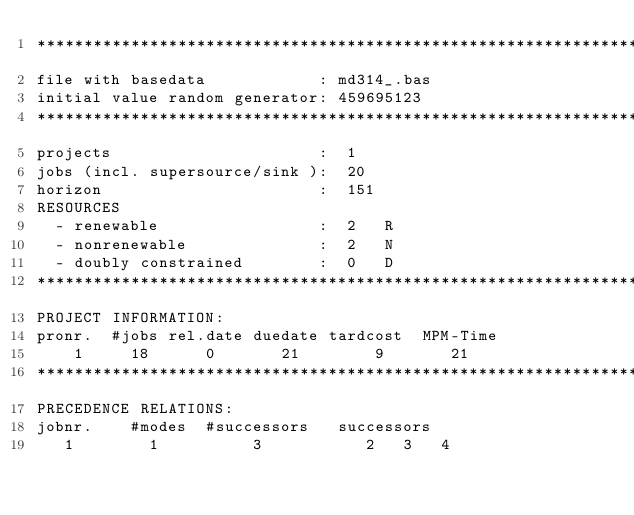Convert code to text. <code><loc_0><loc_0><loc_500><loc_500><_ObjectiveC_>************************************************************************
file with basedata            : md314_.bas
initial value random generator: 459695123
************************************************************************
projects                      :  1
jobs (incl. supersource/sink ):  20
horizon                       :  151
RESOURCES
  - renewable                 :  2   R
  - nonrenewable              :  2   N
  - doubly constrained        :  0   D
************************************************************************
PROJECT INFORMATION:
pronr.  #jobs rel.date duedate tardcost  MPM-Time
    1     18      0       21        9       21
************************************************************************
PRECEDENCE RELATIONS:
jobnr.    #modes  #successors   successors
   1        1          3           2   3   4</code> 